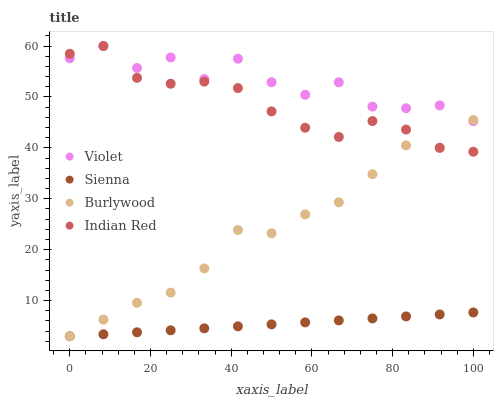Does Sienna have the minimum area under the curve?
Answer yes or no. Yes. Does Violet have the maximum area under the curve?
Answer yes or no. Yes. Does Burlywood have the minimum area under the curve?
Answer yes or no. No. Does Burlywood have the maximum area under the curve?
Answer yes or no. No. Is Sienna the smoothest?
Answer yes or no. Yes. Is Violet the roughest?
Answer yes or no. Yes. Is Burlywood the smoothest?
Answer yes or no. No. Is Burlywood the roughest?
Answer yes or no. No. Does Sienna have the lowest value?
Answer yes or no. Yes. Does Indian Red have the lowest value?
Answer yes or no. No. Does Violet have the highest value?
Answer yes or no. Yes. Does Burlywood have the highest value?
Answer yes or no. No. Is Sienna less than Indian Red?
Answer yes or no. Yes. Is Indian Red greater than Sienna?
Answer yes or no. Yes. Does Indian Red intersect Burlywood?
Answer yes or no. Yes. Is Indian Red less than Burlywood?
Answer yes or no. No. Is Indian Red greater than Burlywood?
Answer yes or no. No. Does Sienna intersect Indian Red?
Answer yes or no. No. 